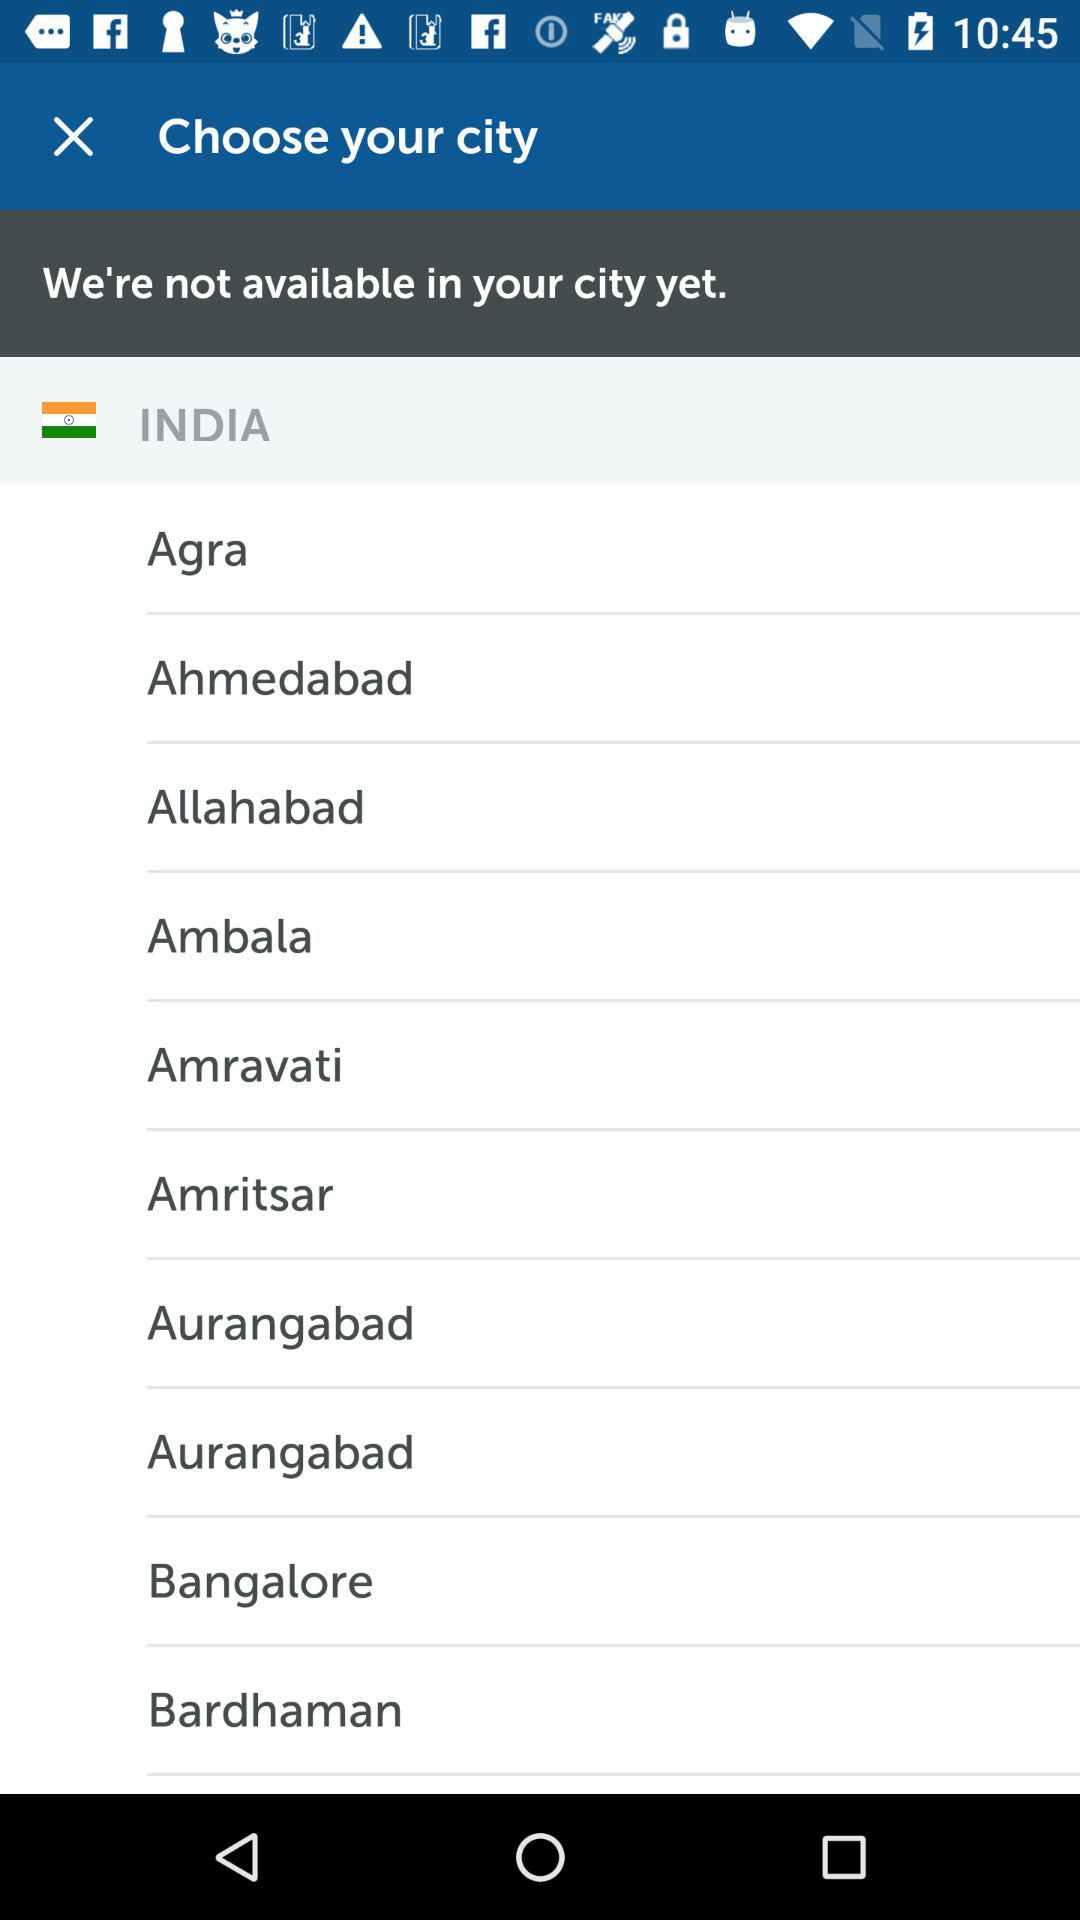What is the country's name? The country's name is "INDIA". 